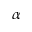Convert formula to latex. <formula><loc_0><loc_0><loc_500><loc_500>\alpha</formula> 